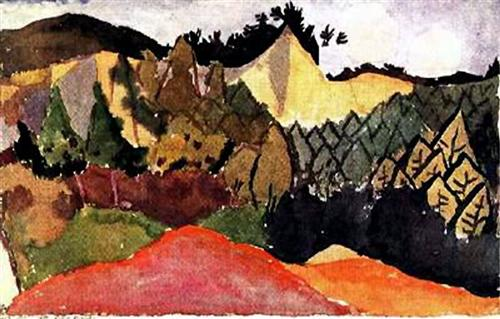Could you elaborate on the techniques used in this painting? Certainly! The painting employs several techniques characteristic of post-impressionism and Fauvism. The use of bold, exaggerated colors is a defining feature, with the artist choosing non-naturalistic shades to convey emotion and atmosphere rather than realism. The brushstrokes are loose and expressive, creating texture and movement within the painting. This technique helps to draw the viewer's eye across the composition and adds a tactile quality to the landscape. The artist also uses contrast effectively, with darker colors and shadows interspersed among the brighter hues to add depth and dimension. Overall, these techniques combine to create a dynamic and immersive visual experience. What emotions do you think the artist was trying to convey through this painting? The use of vibrant, warm colors such as reds, yellows, and greens can evoke a sense of vitality and energy, suggesting an emotional connection to the landscape. The expressive brushstrokes add a layer of movement and spontaneity, potentially reflecting the artist's emotional response to the scenery. The contrast between light and dark areas may also symbolize the interplay of hope and melancholy, capturing the complexity of the natural world. Overall, the artist seems to be conveying a deep, almost visceral appreciation for the landscape, inviting viewers to share in this emotional experience. 